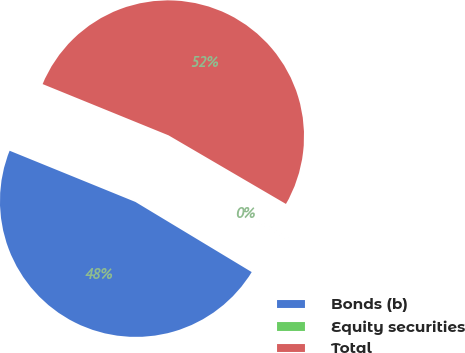<chart> <loc_0><loc_0><loc_500><loc_500><pie_chart><fcel>Bonds (b)<fcel>Equity securities<fcel>Total<nl><fcel>47.52%<fcel>0.22%<fcel>52.27%<nl></chart> 